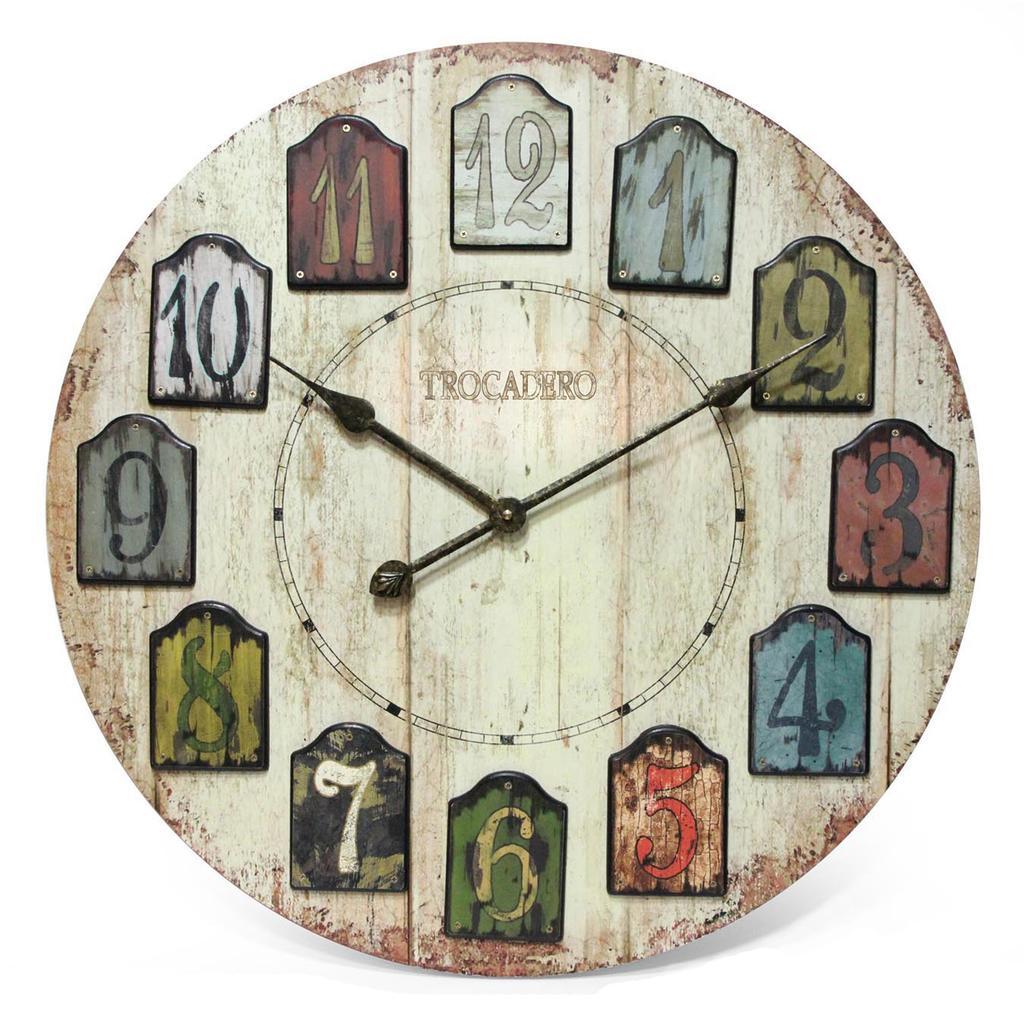<image>
Give a short and clear explanation of the subsequent image. A wooden sign that says Trocadero on the face of it. 